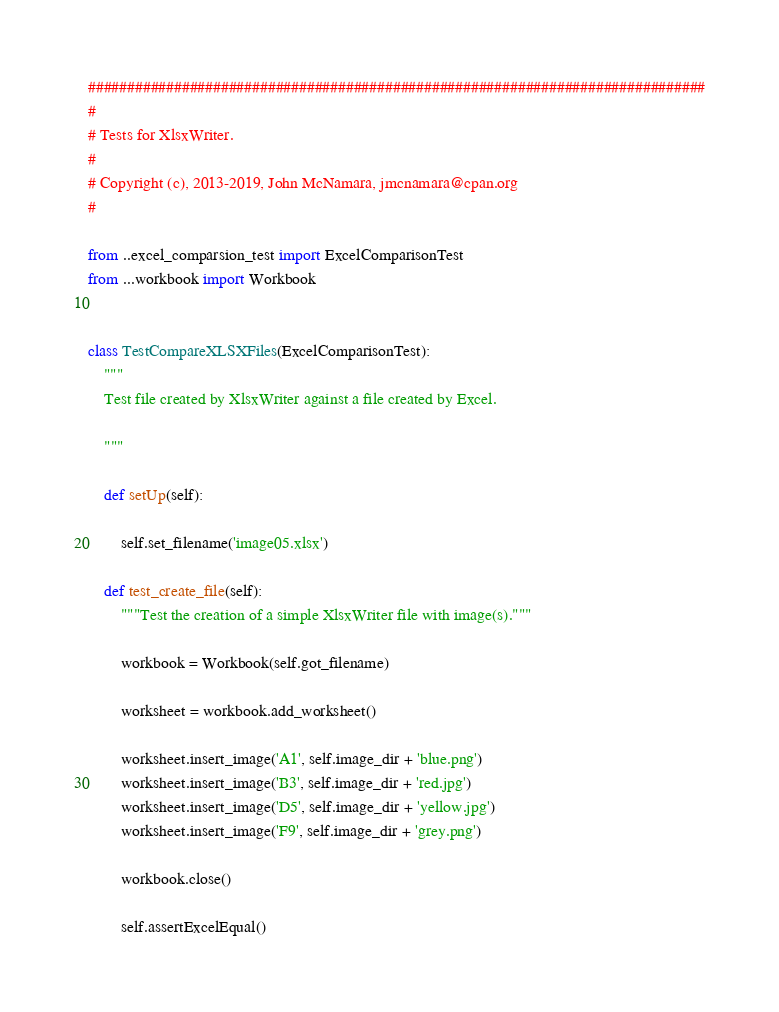<code> <loc_0><loc_0><loc_500><loc_500><_Python_>###############################################################################
#
# Tests for XlsxWriter.
#
# Copyright (c), 2013-2019, John McNamara, jmcnamara@cpan.org
#

from ..excel_comparsion_test import ExcelComparisonTest
from ...workbook import Workbook


class TestCompareXLSXFiles(ExcelComparisonTest):
    """
    Test file created by XlsxWriter against a file created by Excel.

    """

    def setUp(self):

        self.set_filename('image05.xlsx')

    def test_create_file(self):
        """Test the creation of a simple XlsxWriter file with image(s)."""

        workbook = Workbook(self.got_filename)

        worksheet = workbook.add_worksheet()

        worksheet.insert_image('A1', self.image_dir + 'blue.png')
        worksheet.insert_image('B3', self.image_dir + 'red.jpg')
        worksheet.insert_image('D5', self.image_dir + 'yellow.jpg')
        worksheet.insert_image('F9', self.image_dir + 'grey.png')

        workbook.close()

        self.assertExcelEqual()
</code> 